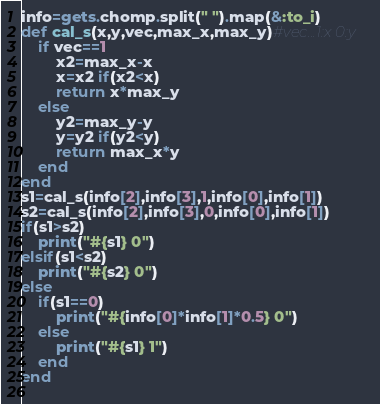Convert code to text. <code><loc_0><loc_0><loc_500><loc_500><_Ruby_>info=gets.chomp.split(" ").map(&:to_i)
def cal_s(x,y,vec,max_x,max_y)#vec...1:x 0:y
	if vec==1
		x2=max_x-x
		x=x2 if(x2<x)
		return x*max_y
	else
		y2=max_y-y
		y=y2 if(y2<y)
		return max_x*y
	end
end
s1=cal_s(info[2],info[3],1,info[0],info[1])
s2=cal_s(info[2],info[3],0,info[0],info[1])
if(s1>s2)
	print("#{s1} 0")
elsif(s1<s2)
	print("#{s2} 0")
else
	if(s1==0)
		print("#{info[0]*info[1]*0.5} 0")
	else
		print("#{s1} 1")
	end
end
		</code> 